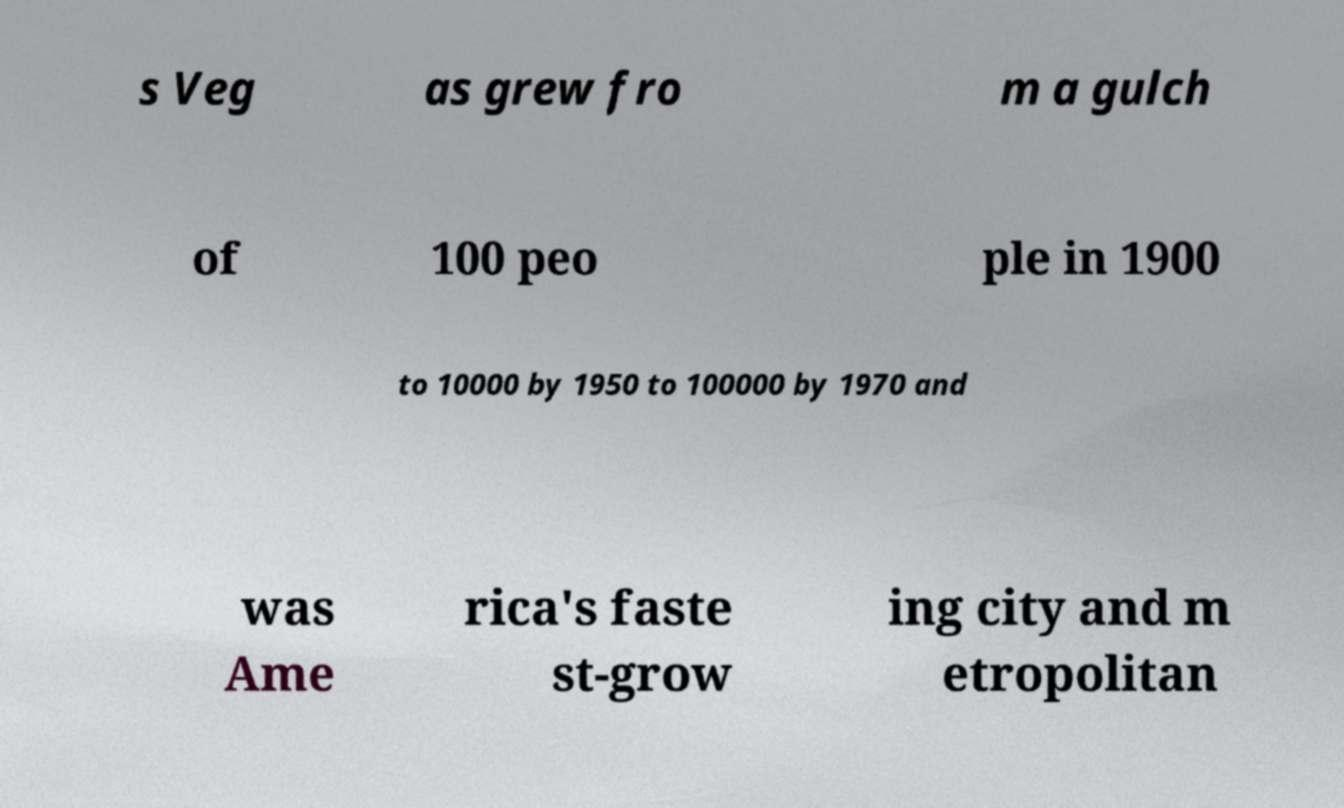Could you assist in decoding the text presented in this image and type it out clearly? s Veg as grew fro m a gulch of 100 peo ple in 1900 to 10000 by 1950 to 100000 by 1970 and was Ame rica's faste st-grow ing city and m etropolitan 